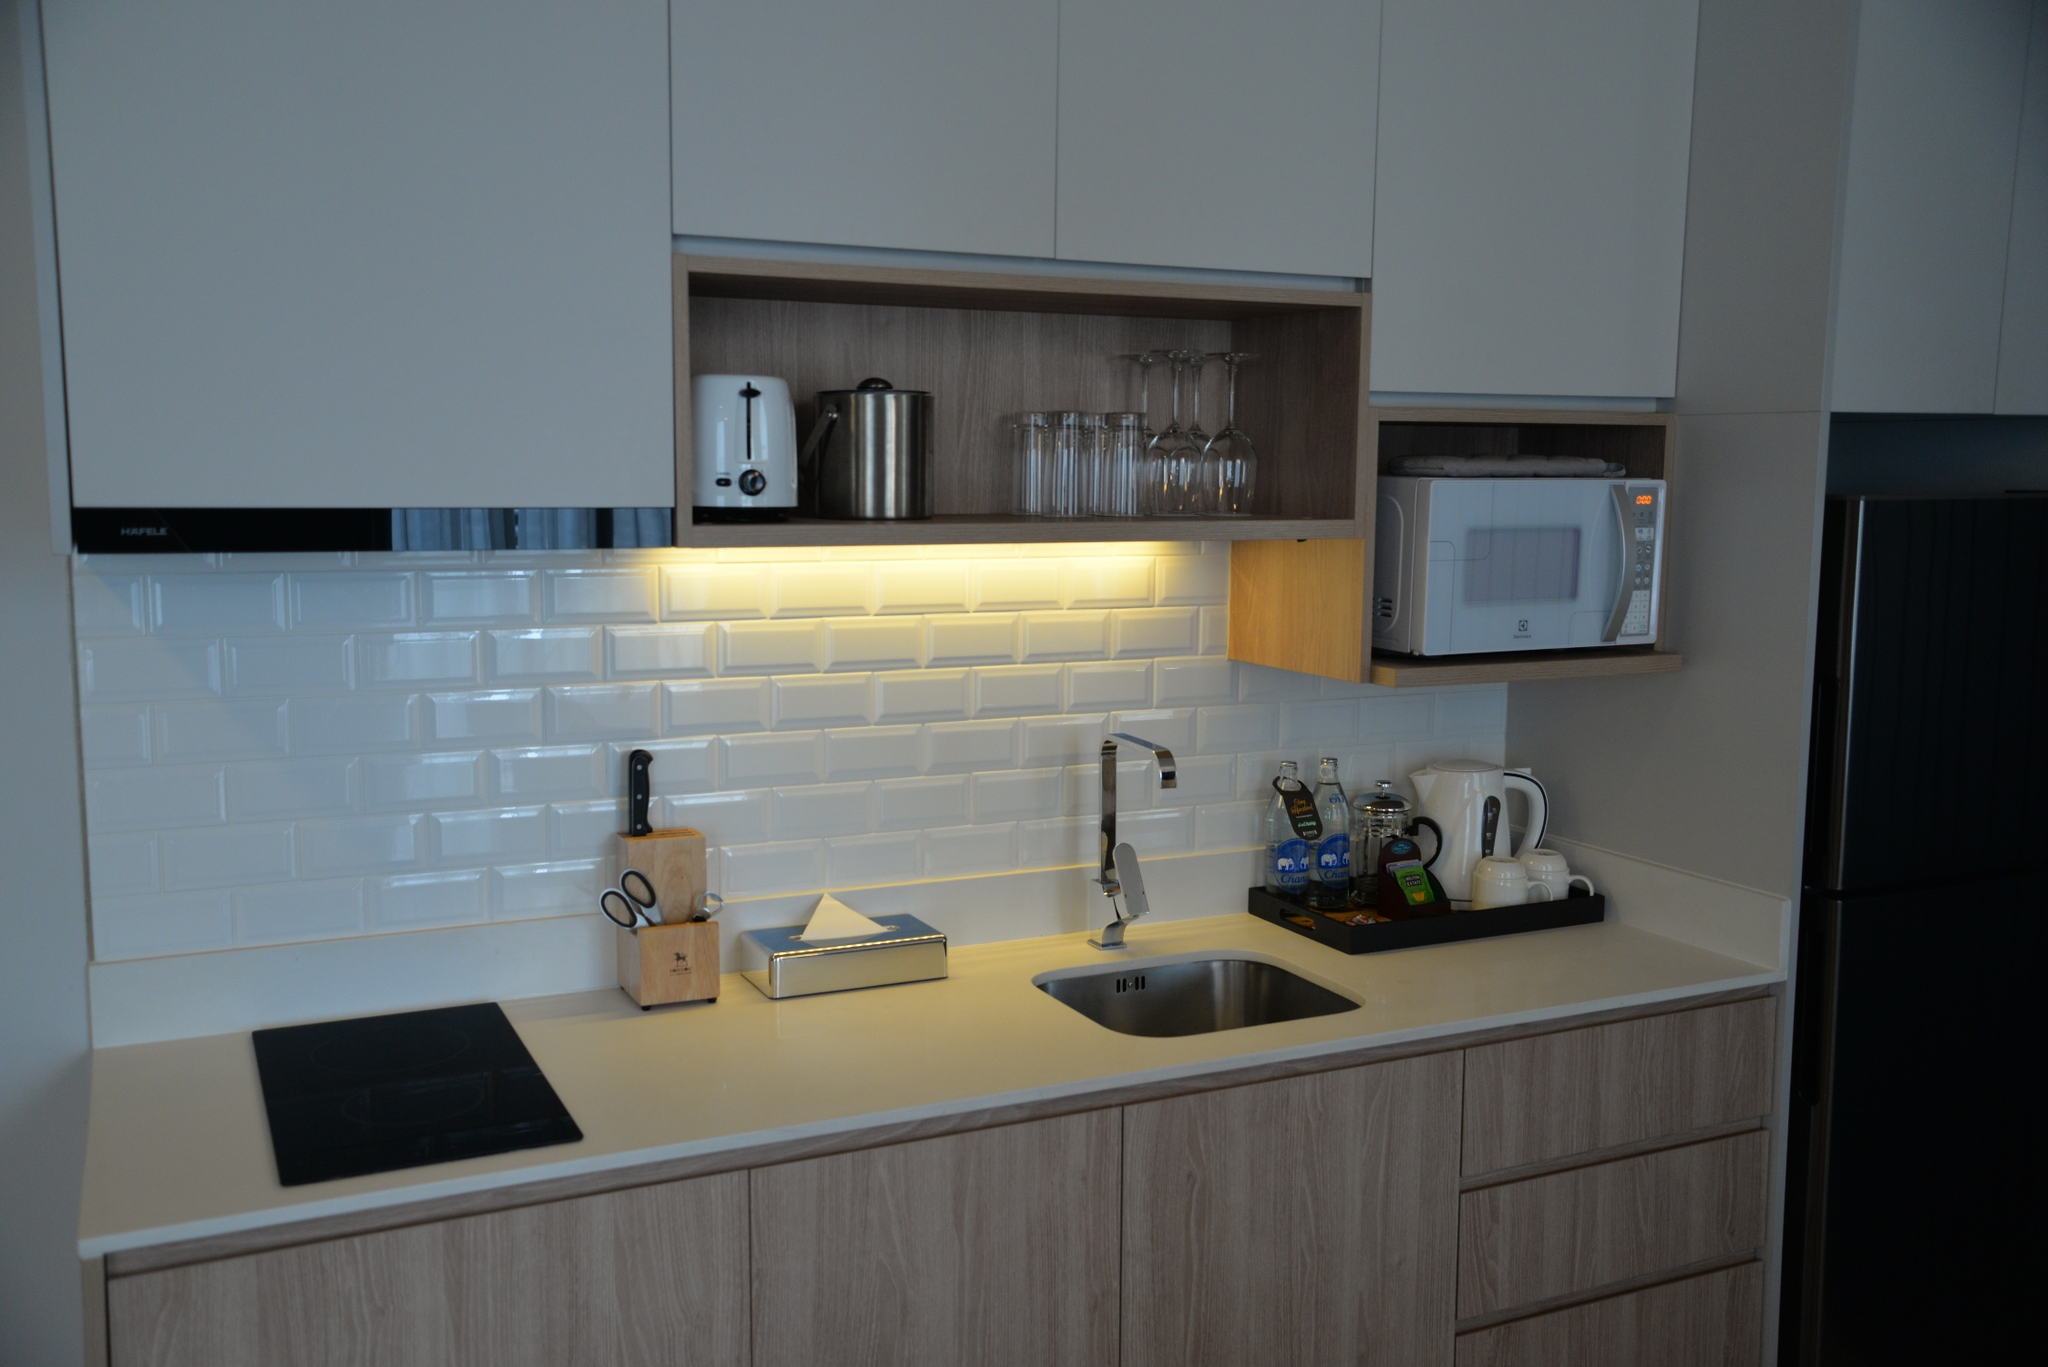What kind of daily life scenario do you imagine unfolding in this kitchen? In this kitchen, imagine a busy weekday morning starting with the soft hum of a coffee maker brewing the first cup of the day while the toaster crisps slices of bread to perfection. Natural light streams in through the window, energizing the space as breakfast is prepared. As the household begins its day, family members gather around the countertop, effortlessly preparing various breakfast items. The induction cooktop quickly heats up a pan for frying eggs, while the kettle boils water for tea. Throughout the day, different meals are seamlessly prepared, cleaned, and stored, thanks to the thoughtfully designed cabinets and integrated appliances. Evenings bring a warm glow from the under-cabinet lighting, setting the stage for a relaxed cooking experience as the microwave and oven perfectly coordinate to create a delicious dinner. This kitchen supports the dynamic flow of the household with its modern amenities and inviting ambiance. Could you provide a shorter daily life scenario? A typical day in this kitchen might start with the coffee maker brewing the morning coffee while the toaster crisps bread. Natural light fills the room as a person prepares a quick breakfast using the induction cooktop. Later, the kitchen remains organized and functional, with small appliances and ample storage making meal prep seamless. In the evening, the under-cabinet lights create a warm atmosphere perfect for a relaxing dinner preparation.  If this kitchen were part of an intergalactic spaceship, how would it function and what features would it have? In an intergalactic spaceship, this kitchen would be highly automated and equipped with advanced technology to accommodate life in space. The countertop would be integrated with multi-functional synthesizers capable of creating a variety of meals from stored molecular bases. The cabinetry would use anti-gravity technology to securely store items, preventing them from floating during zero-gravity conditions. The sink would feature water recycling technology, purifying and reusing water efficiently. An AI system would manage inventory, informing the user of ingredients and suggesting space-friendly recipes. The induction cooktop would have magnetic assistance to keep cookware stable. Additionally, the backsplash would be an interactive smart display, providing everything from cooking tutorials to communication with the rest of the spaceship. The microwave and other small appliances would be miniaturized and energy-efficient, ensuring optimal use of limited space and resources. 